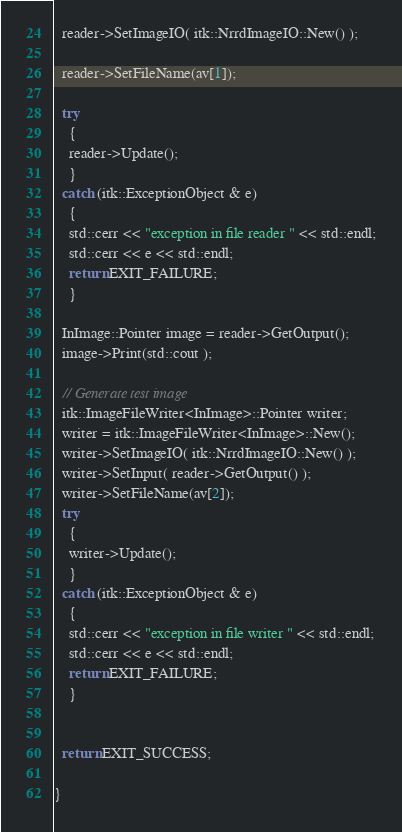Convert code to text. <code><loc_0><loc_0><loc_500><loc_500><_C++_>  reader->SetImageIO( itk::NrrdImageIO::New() );

  reader->SetFileName(av[1]);

  try
    {
    reader->Update();
    }
  catch (itk::ExceptionObject & e)
    {
    std::cerr << "exception in file reader " << std::endl;
    std::cerr << e << std::endl;
    return EXIT_FAILURE;
    }

  InImage::Pointer image = reader->GetOutput();
  image->Print(std::cout );

  // Generate test image
  itk::ImageFileWriter<InImage>::Pointer writer;
  writer = itk::ImageFileWriter<InImage>::New();
  writer->SetImageIO( itk::NrrdImageIO::New() );
  writer->SetInput( reader->GetOutput() );
  writer->SetFileName(av[2]);
  try
    {
    writer->Update();
    }
  catch (itk::ExceptionObject & e)
    {
    std::cerr << "exception in file writer " << std::endl;
    std::cerr << e << std::endl;
    return EXIT_FAILURE;
    }


  return EXIT_SUCCESS;

}
</code> 